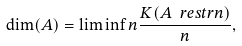Convert formula to latex. <formula><loc_0><loc_0><loc_500><loc_500>\dim ( A ) = \liminf n \frac { K ( A \ r e s t r n ) } { n } ,</formula> 